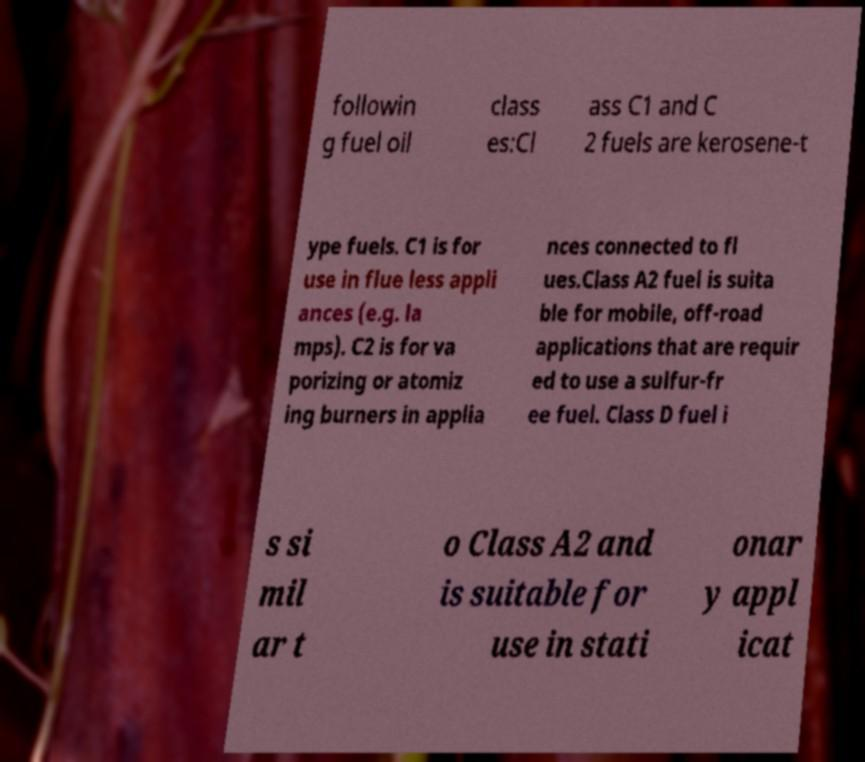What messages or text are displayed in this image? I need them in a readable, typed format. followin g fuel oil class es:Cl ass C1 and C 2 fuels are kerosene-t ype fuels. C1 is for use in flue less appli ances (e.g. la mps). C2 is for va porizing or atomiz ing burners in applia nces connected to fl ues.Class A2 fuel is suita ble for mobile, off-road applications that are requir ed to use a sulfur-fr ee fuel. Class D fuel i s si mil ar t o Class A2 and is suitable for use in stati onar y appl icat 